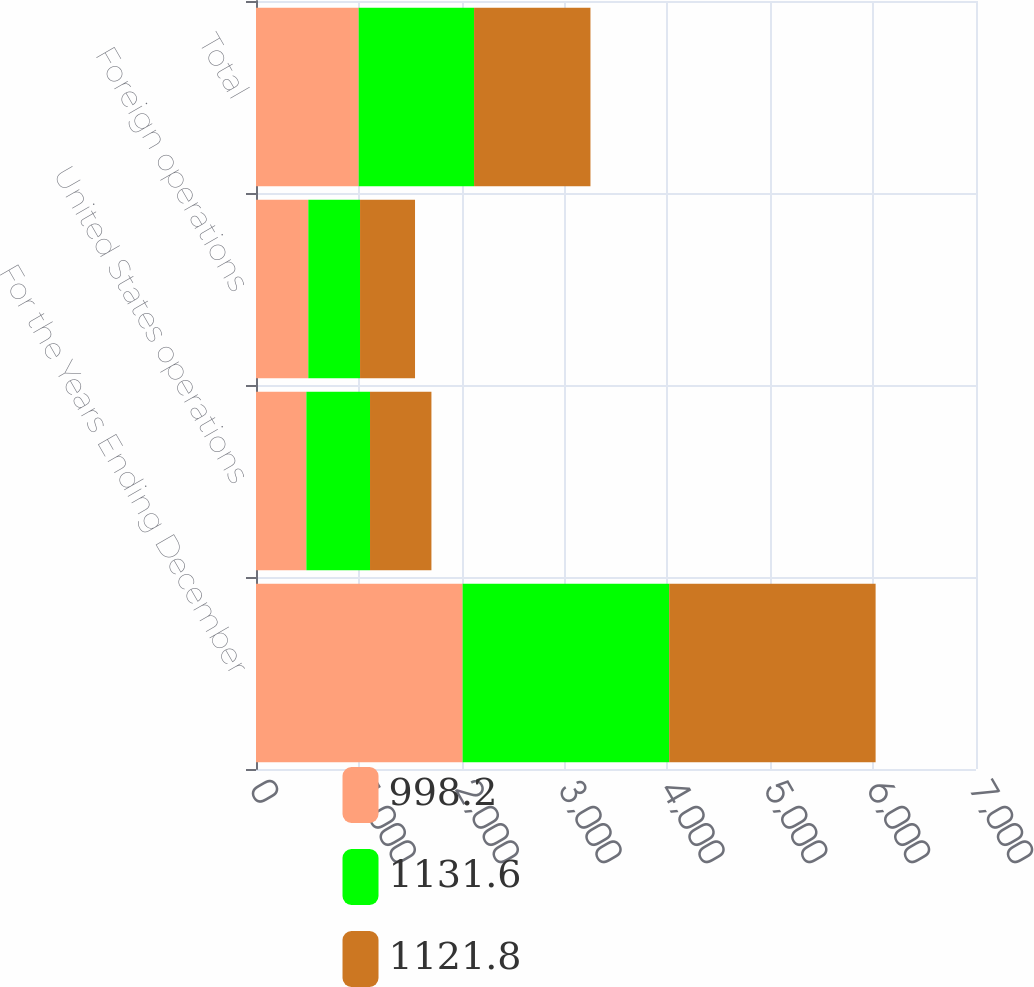<chart> <loc_0><loc_0><loc_500><loc_500><stacked_bar_chart><ecel><fcel>For the Years Ending December<fcel>United States operations<fcel>Foreign operations<fcel>Total<nl><fcel>998.2<fcel>2009<fcel>489.7<fcel>508.5<fcel>998.2<nl><fcel>1131.6<fcel>2008<fcel>618.8<fcel>503<fcel>1121.8<nl><fcel>1121.8<fcel>2007<fcel>597<fcel>534.6<fcel>1131.6<nl></chart> 